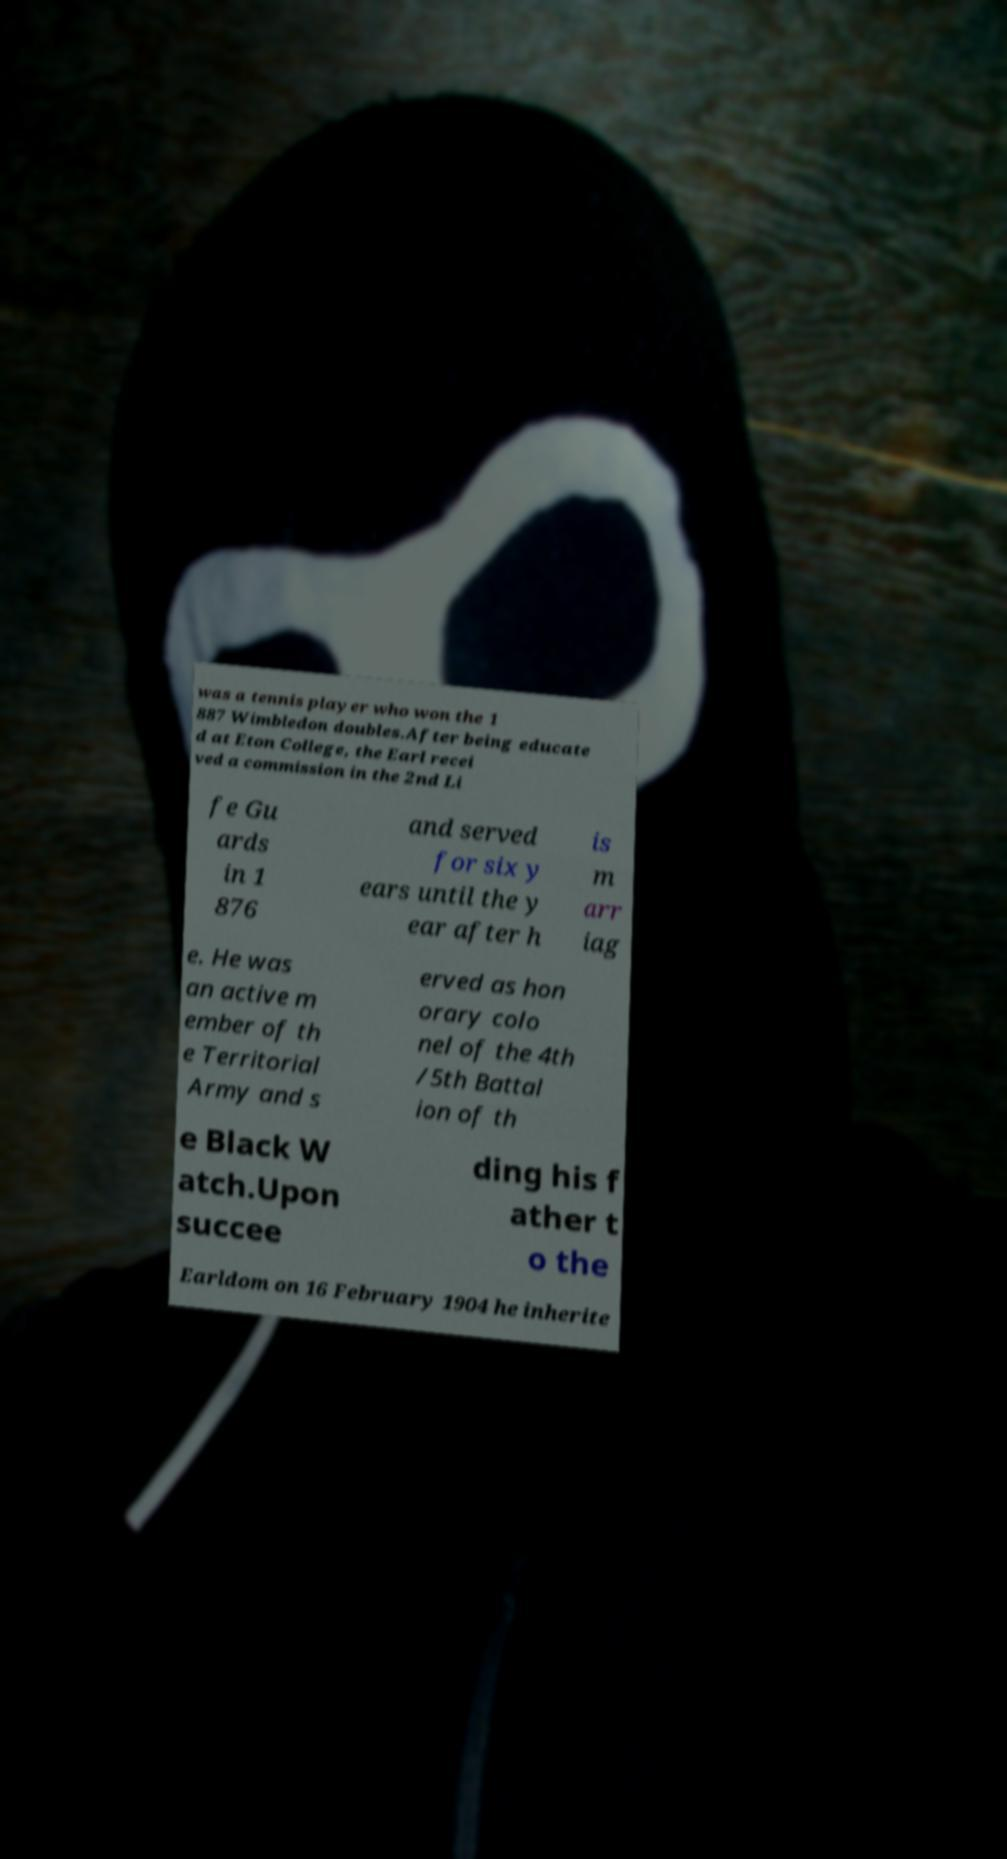Can you read and provide the text displayed in the image?This photo seems to have some interesting text. Can you extract and type it out for me? was a tennis player who won the 1 887 Wimbledon doubles.After being educate d at Eton College, the Earl recei ved a commission in the 2nd Li fe Gu ards in 1 876 and served for six y ears until the y ear after h is m arr iag e. He was an active m ember of th e Territorial Army and s erved as hon orary colo nel of the 4th /5th Battal ion of th e Black W atch.Upon succee ding his f ather t o the Earldom on 16 February 1904 he inherite 